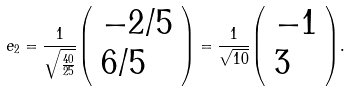Convert formula to latex. <formula><loc_0><loc_0><loc_500><loc_500>e _ { 2 } = { \frac { 1 } { \sqrt { \frac { 4 0 } { 2 5 } } } } { \left ( \begin{array} { l } { - 2 / 5 } \\ { 6 / 5 } \end{array} \right ) } = { \frac { 1 } { \sqrt { 1 0 } } } { \left ( \begin{array} { l } { - 1 } \\ { 3 } \end{array} \right ) } .</formula> 